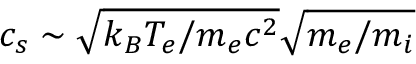<formula> <loc_0><loc_0><loc_500><loc_500>c _ { s } \sim \sqrt { k _ { B } T _ { e } / m _ { e } c ^ { 2 } } \sqrt { m _ { e } / m _ { i } }</formula> 